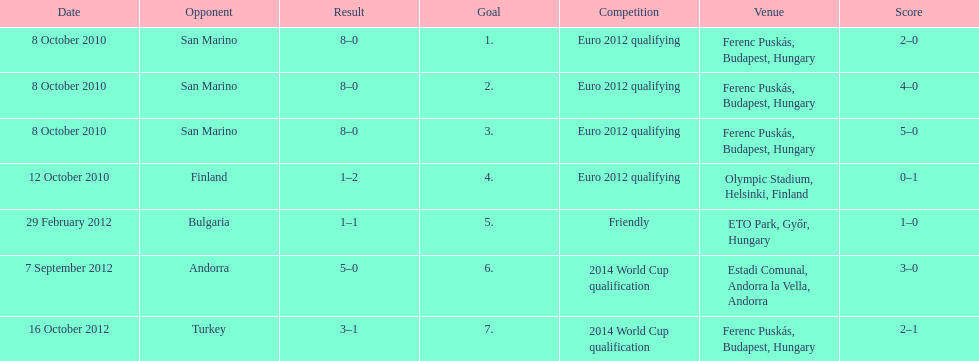Szalai scored all but one of his international goals in either euro 2012 qualifying or what other level of play? 2014 World Cup qualification. 